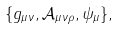<formula> <loc_0><loc_0><loc_500><loc_500>\{ g _ { \mu \nu } , \mathcal { A } _ { \mu \nu \rho } , \psi _ { \mu } \} ,</formula> 